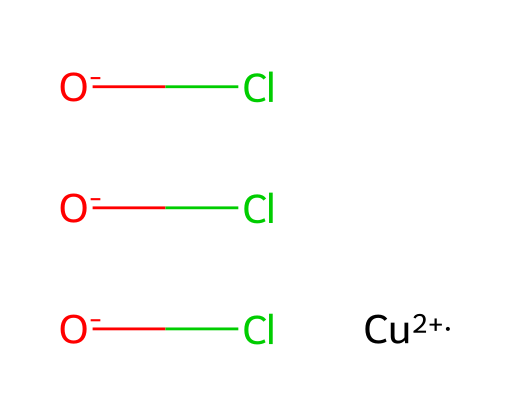What is the molecular formula of copper oxychloride? By analyzing the components in the SMILES representation, we can identify that there is one copper atom (Cu), three chlorine atoms (Cl), and two oxygen atoms (O). Therefore, the molecular formula can be derived as CuCl3O2.
Answer: CuCl3O2 How many oxygen atoms are present in copper oxychloride? The SMILES notation indicates the presence of two [O-] nodes which represent oxygen atoms. Counting them gives us a total of two oxygen atoms.
Answer: 2 What is the oxidation state of copper in copper oxychloride? The notation [Cu+2] indicates that the oxidation state of copper in this compound is +2. This can be inferred directly from the SMILES representation.
Answer: +2 How many bonds does the copper atom form in copper oxychloride? The SMILES structure shows that copper is bonded to three chloride ions and two oxide ions. This indicates it forms multiple coordination bonds, totaling five in this situation.
Answer: 5 Is copper oxychloride a systemic or contact fungicide? Since copper oxychloride acts on contact with the pathogens on plant surfaces and does not move within the plant tissues, it is classified as a contact fungicide.
Answer: contact What type of chemical bond is primarily present in copper oxychloride? The SMILES representation displays the interactions between copper, oxygen, and chlorine atoms. Given this combination, copper oxychloride primarily consists of ionic bonds due to the electrostatic attractions between the charged ions.
Answer: ionic What is the primary use of copper oxychloride in gardening? Copper oxychloride is primarily used as a fungicide to control a variety of fungal infections in crops and ornamental plants, making it widely used in agricultural practices.
Answer: fungicide 